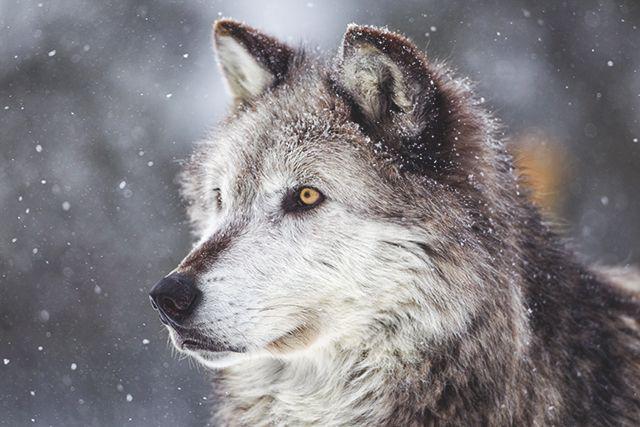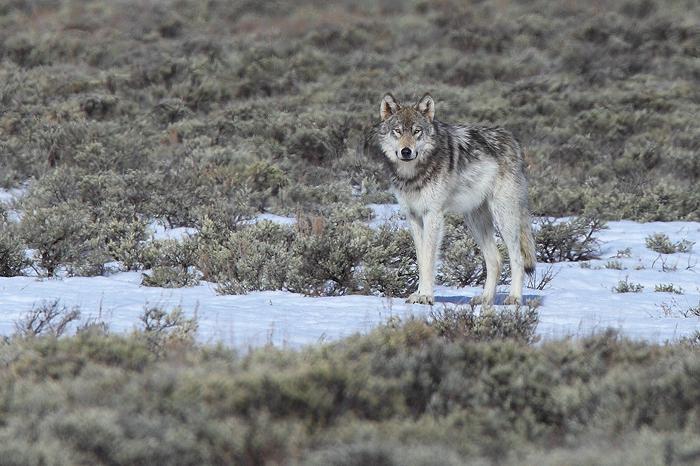The first image is the image on the left, the second image is the image on the right. For the images shown, is this caption "Each image contains exactly one wolf, and one image features a wolf that is standing still and looking toward the camera." true? Answer yes or no. Yes. The first image is the image on the left, the second image is the image on the right. For the images displayed, is the sentence "The wolves are in a group in at least one picture." factually correct? Answer yes or no. No. 